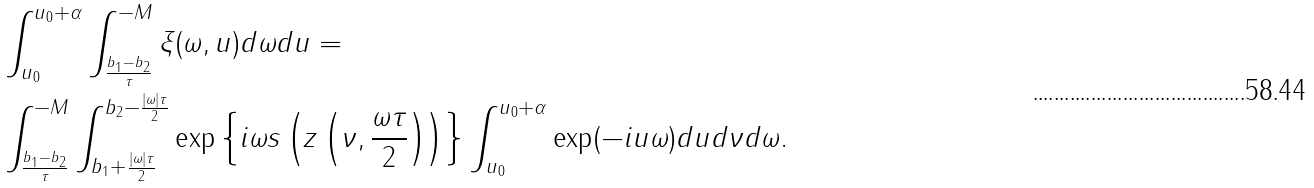<formula> <loc_0><loc_0><loc_500><loc_500>& \int _ { u _ { 0 } } ^ { u _ { 0 } + \alpha } \int _ { \frac { b _ { 1 } - b _ { 2 } } { \tau } } ^ { - M } \xi ( \omega , u ) d \omega d u = \\ & \int _ { \frac { b _ { 1 } - b _ { 2 } } { \tau } } ^ { - M } \int _ { b _ { 1 } + \frac { | \omega | \tau } { 2 } } ^ { b _ { 2 } - \frac { | \omega | \tau } { 2 } } \exp \left \{ i \omega s \left ( z \left ( \nu , \frac { \omega \tau } { 2 } \right ) \right ) \right \} \int _ { u _ { 0 } } ^ { u _ { 0 } + \alpha } \exp ( - i u \omega ) d u d \nu d \omega .</formula> 